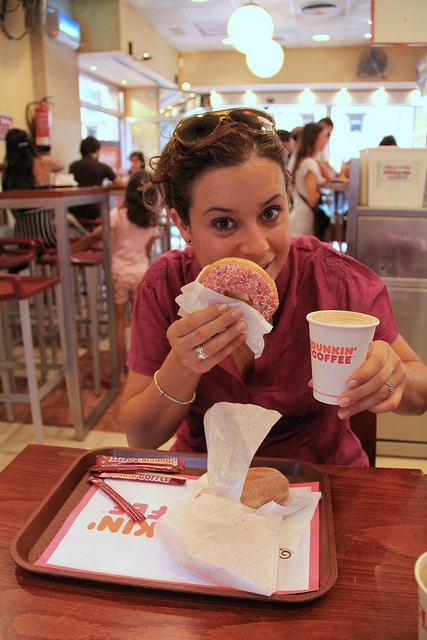Describe the objects in this image and their specific colors. I can see dining table in maroon, brown, tan, and lightgray tones, people in maroon, brown, and black tones, dining table in maroon and brown tones, people in maroon, brown, black, and salmon tones, and chair in maroon, gray, and brown tones in this image. 